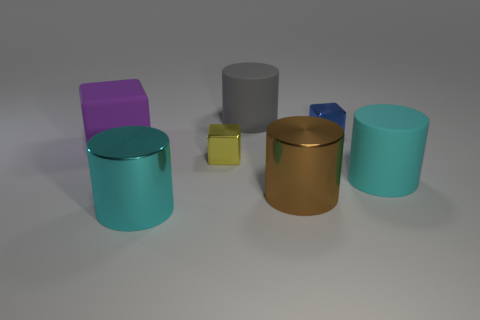Are there fewer large gray objects that are in front of the big brown cylinder than tiny brown cylinders? While it's clear that there are multiple objects within the image, determining the exact count of objects positioned specifically in front of the big brown cylinder, as well as comparing them to the quantity of tiny brown cylinders, requires a subjective judgment due to the 2D representation of the image. That being said, based on the given perspective, there appears to be one large gray cylinder in front of the big brown one and no tiny brown cylinders at all. Therefore, the correct answer should technically be 'yes', as there are none of the latter to compare to. 